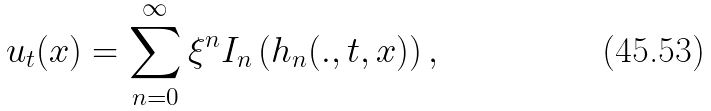<formula> <loc_0><loc_0><loc_500><loc_500>u _ { t } ( x ) = \sum _ { n = 0 } ^ { \infty } \xi ^ { n } I _ { n } \left ( h _ { n } ( . , t , x ) \right ) ,</formula> 